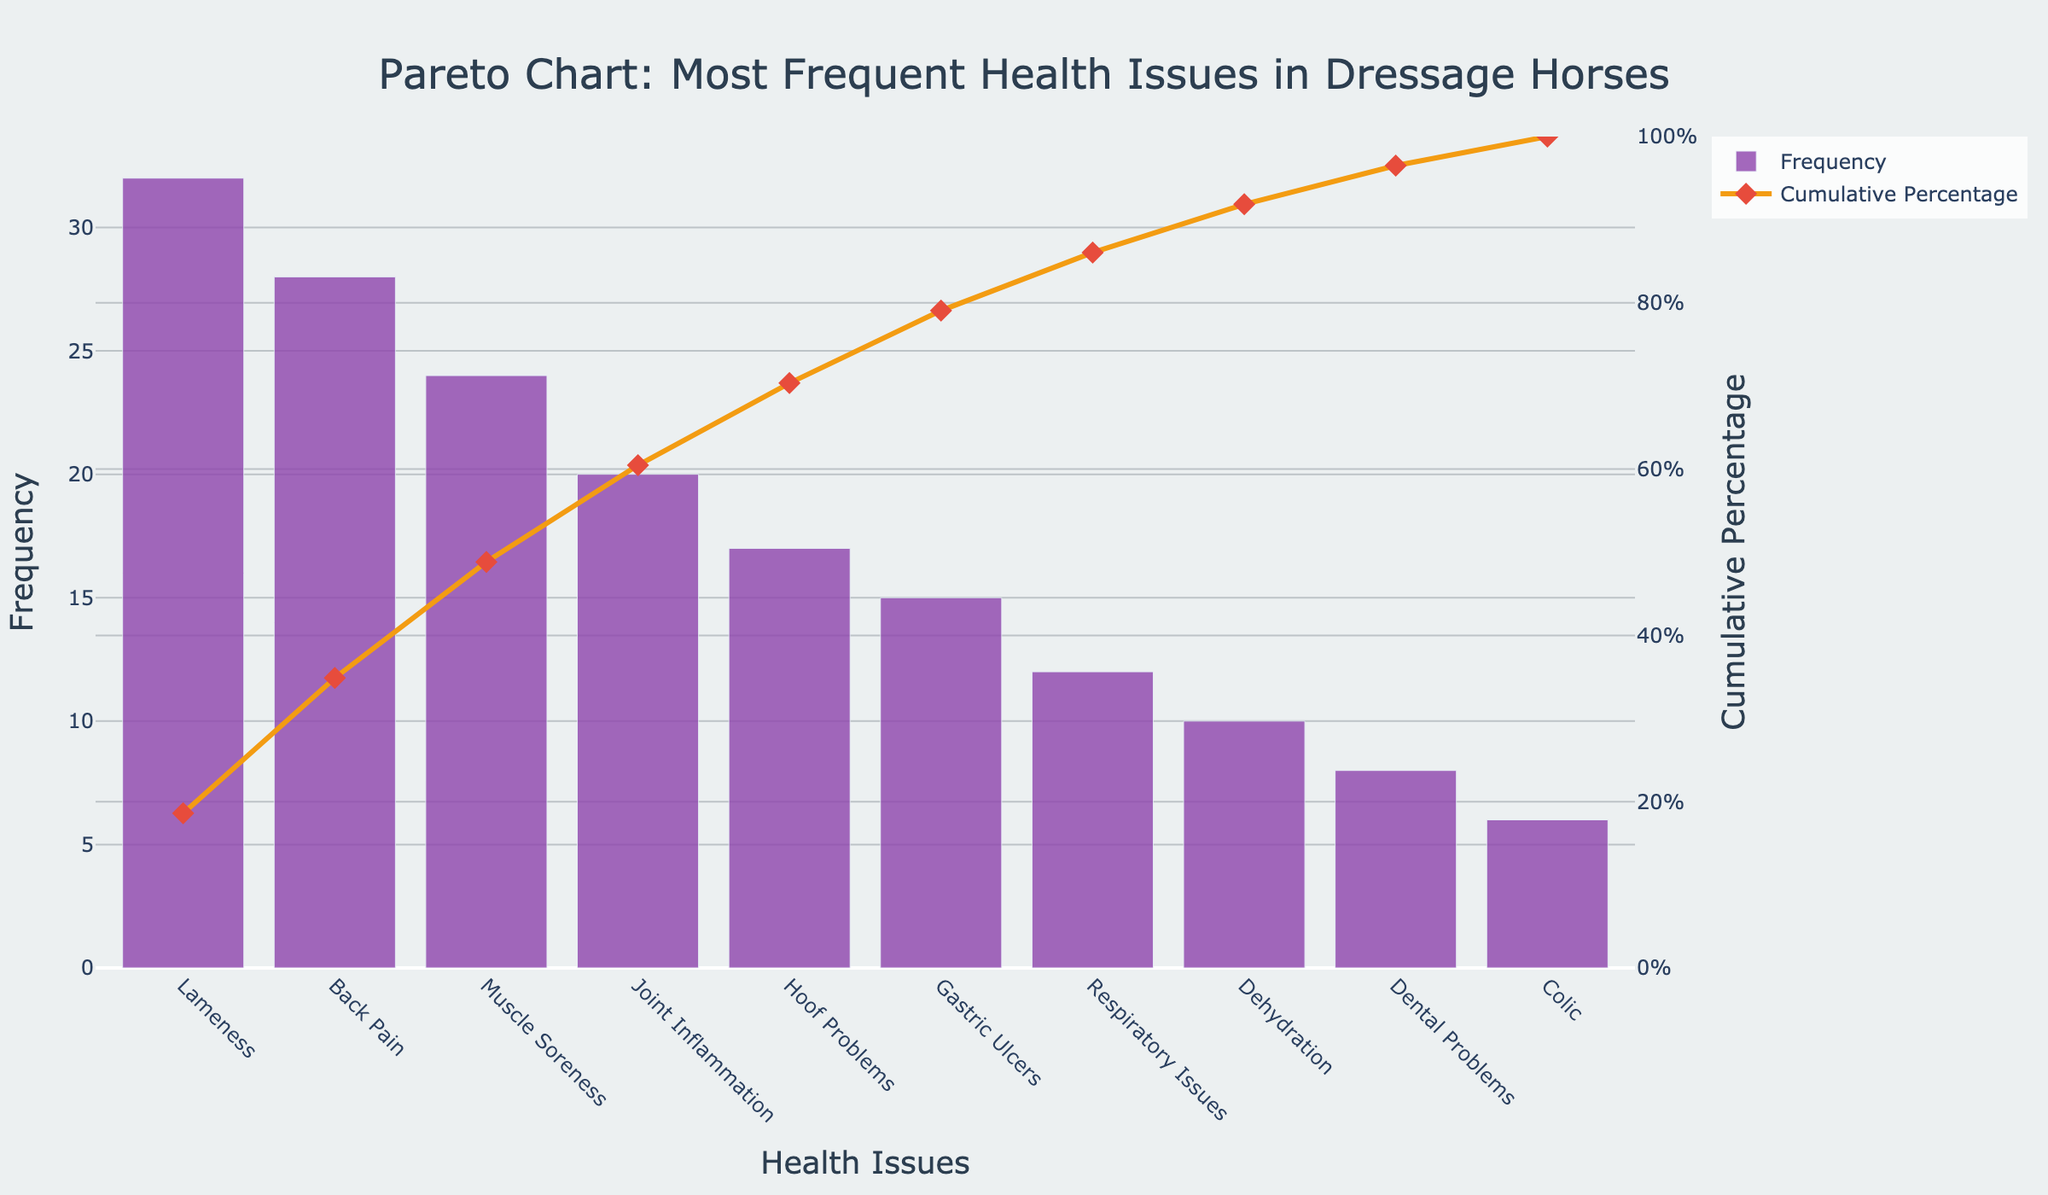What's the title of the chart? The title of the chart is at the top center and reads "Pareto Chart: Most Frequent Health Issues in Dressage Horses."
Answer: Pareto Chart: Most Frequent Health Issues in Dressage Horses What is the most frequent health issue among dressage horses? The first bar, which is the tallest and located at the far left, represents the most frequent health issue. The label beneath this bar is "Lameness."
Answer: Lameness What's the frequency difference between Muscle Soreness and Back Pain? The height of the bar for Muscle Soreness is 24, and the height of the bar for Back Pain is 28. The difference is calculated as 28 - 24.
Answer: 4 Which health issue has the lowest frequency, and what is its value? The last bar, which is the shortest and located at the far right, represents the health issue with the lowest frequency. The label beneath this bar is "Colic," and the value of its height is 6.
Answer: Colic, 6 What percentage of the total issues does Lameness represent? The cumulative percentage line directly above the Lameness bar shows a marker at that position, and from the y-axis on the right side, we can read the cumulative percentage value for Lameness, which is approximately 12.8%.
Answer: Approximately 12.8% List the health issues that account for at least 50% of the cumulative percentage. The cumulative percentage line intersects with the 50% mark around the health issue "Joint Inflammation." Listing from the leftmost bar toward this point: Lameness, Back Pain, Muscle Soreness, Joint Inflammation.
Answer: Lameness, Back Pain, Muscle Soreness, Joint Inflammation What's the cumulative percentage after including Respiratory Issues? The cumulative percentage line at the point directly above the Respiratory Issues bar intersects with the y-axis on the right. It reads approximately 87.5%.
Answer: Approximately 87.5% Which health issue's bar contributes to surpassing the 70% cumulative percentage mark? The cumulative percentage line passes the 70% mark between the bars for Hoof Problems and Gastric Ulcers. The issue directly to the left of this point is "Hoof Problems."
Answer: Hoof Problems How many health issues have a frequency of 15 or more? The bars from left to right until the frequency value falls below 15 are counted. These bars end at Gastric Ulcers. The health issues are: Lameness, Back Pain, Muscle Soreness, Joint Inflammation, Hoof Problems, and Gastric Ulcers, which total 6.
Answer: 6 Between Back Pain and Joint Inflammation, which has a higher cumulative percentage, and what's the difference? By looking at the markers on the cumulative percentage line for Back Pain and Joint Inflammation: Back Pain's cumulative percentage is approximately 25.6%, and for Joint Inflammation, it’s around 64.1%. The difference is 64.1% - 25.6%.
Answer: Joint Inflammation, approximately 38.5% 